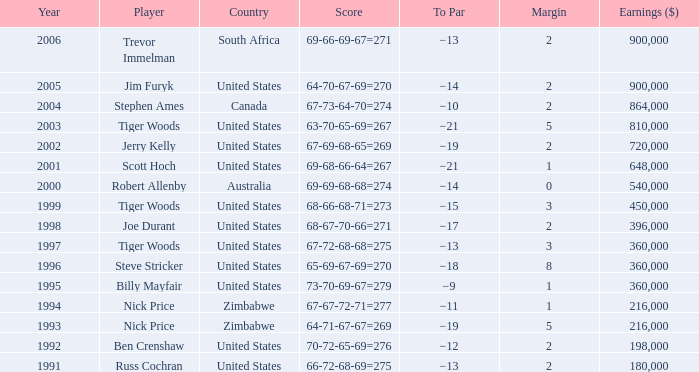How many years has a player comparable to joe durant accumulated, with earnings surpassing $396,000? 0.0. 